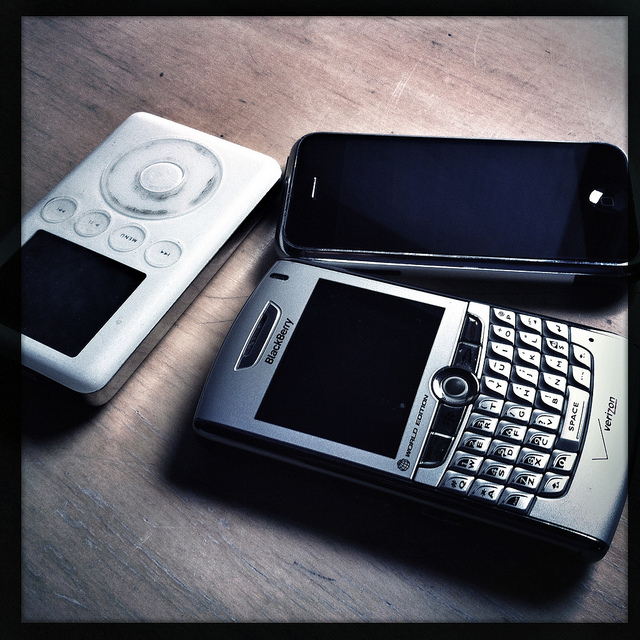Please identify all text content in this image. BlackBerry EDITION WORLD verizon N 0 H L I 2 C N SPACE G S 